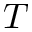<formula> <loc_0><loc_0><loc_500><loc_500>T</formula> 